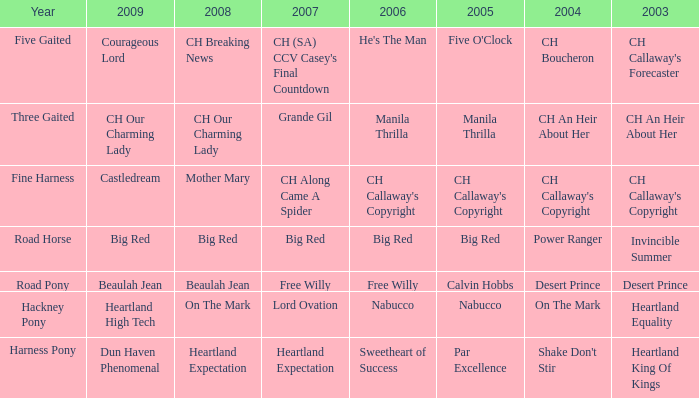What's the significance of 2007 in relation to the 2003 desert prince? Free Willy. 